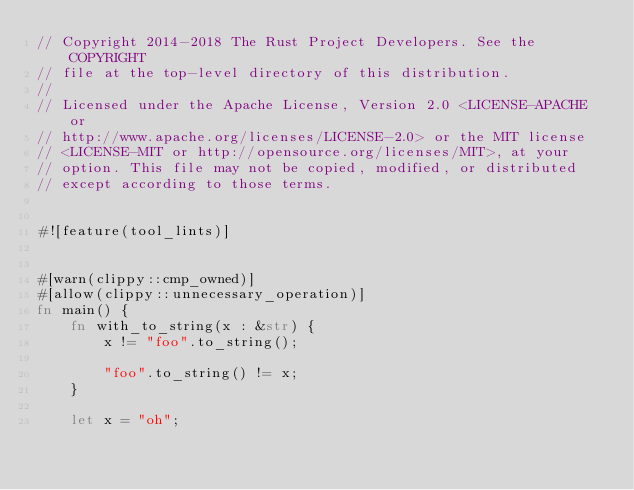<code> <loc_0><loc_0><loc_500><loc_500><_Rust_>// Copyright 2014-2018 The Rust Project Developers. See the COPYRIGHT
// file at the top-level directory of this distribution.
//
// Licensed under the Apache License, Version 2.0 <LICENSE-APACHE or
// http://www.apache.org/licenses/LICENSE-2.0> or the MIT license
// <LICENSE-MIT or http://opensource.org/licenses/MIT>, at your
// option. This file may not be copied, modified, or distributed
// except according to those terms.


#![feature(tool_lints)]


#[warn(clippy::cmp_owned)]
#[allow(clippy::unnecessary_operation)]
fn main() {
    fn with_to_string(x : &str) {
        x != "foo".to_string();

        "foo".to_string() != x;
    }

    let x = "oh";
</code> 